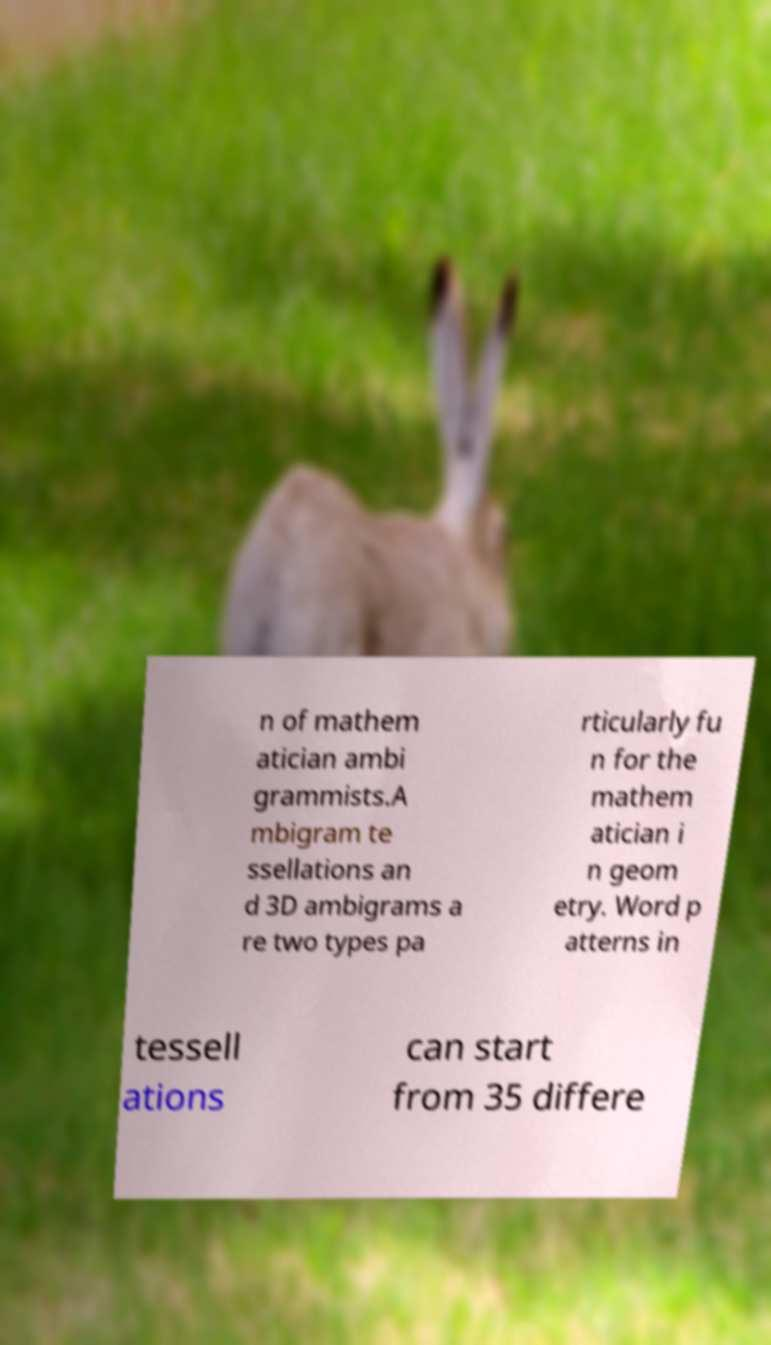What messages or text are displayed in this image? I need them in a readable, typed format. n of mathem atician ambi grammists.A mbigram te ssellations an d 3D ambigrams a re two types pa rticularly fu n for the mathem atician i n geom etry. Word p atterns in tessell ations can start from 35 differe 